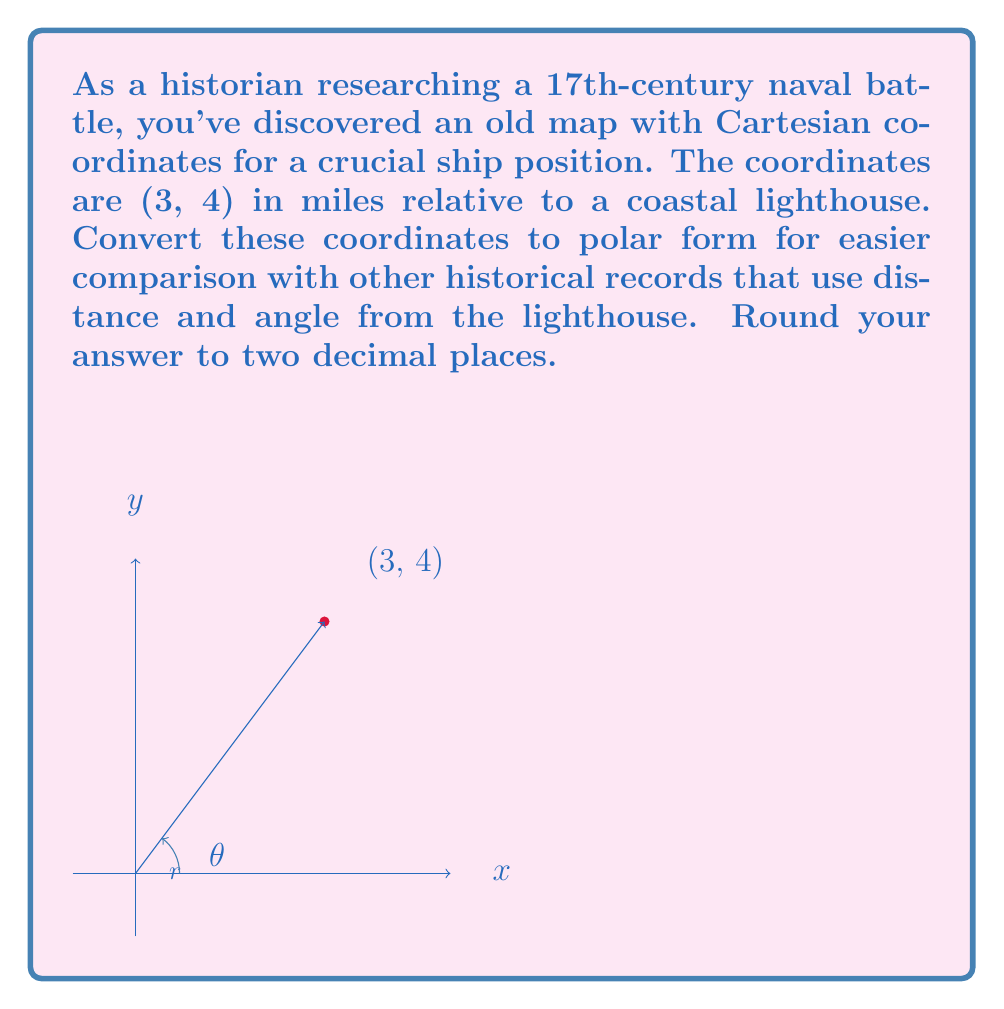Teach me how to tackle this problem. To convert from Cartesian coordinates $(x, y)$ to polar coordinates $(r, \theta)$, we use the following formulas:

1) $r = \sqrt{x^2 + y^2}$
2) $\theta = \tan^{-1}(\frac{y}{x})$

Given $(x, y) = (3, 4)$:

1) Calculate $r$:
   $r = \sqrt{3^2 + 4^2} = \sqrt{9 + 16} = \sqrt{25} = 5$ miles

2) Calculate $\theta$:
   $\theta = \tan^{-1}(\frac{4}{3}) \approx 0.9273$ radians

3) Convert radians to degrees:
   $0.9273 \text{ radians} \times \frac{180°}{\pi} \approx 53.13°$

Therefore, the polar coordinates are $(5, 53.13°)$.
Answer: $(5.00, 53.13°)$ 